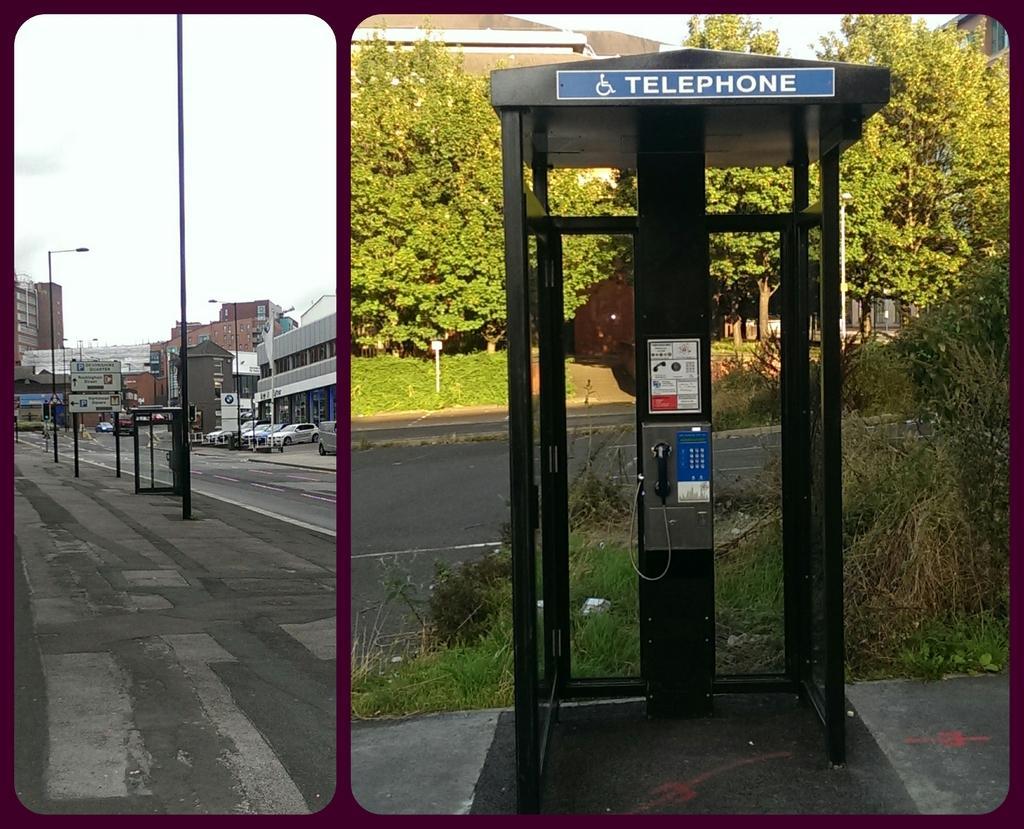In one or two sentences, can you explain what this image depicts? This is a collage picture. On the right side we can see a telephone booth, road, trees, plants, the sky and grass. On the left side we can see the sky, poles, light poles, buildings, booth, vehicles on the road. 